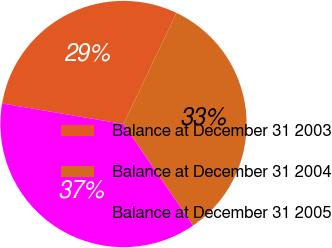Convert chart to OTSL. <chart><loc_0><loc_0><loc_500><loc_500><pie_chart><fcel>Balance at December 31 2003<fcel>Balance at December 31 2004<fcel>Balance at December 31 2005<nl><fcel>29.41%<fcel>33.33%<fcel>37.25%<nl></chart> 